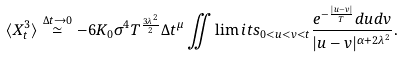Convert formula to latex. <formula><loc_0><loc_0><loc_500><loc_500>\langle { X } _ { t } ^ { 3 } \rangle \stackrel { \Delta t \to 0 } \simeq - 6 K _ { 0 } \sigma ^ { 4 } T ^ { \frac { 3 \lambda ^ { 2 } } { 2 } } \Delta t ^ { \mu } \iint \lim i t s _ { 0 < u < v < t } \frac { e ^ { - \frac { | u - v | } { T } } d u d v } { | u - v | ^ { \alpha + 2 \lambda ^ { 2 } } } .</formula> 